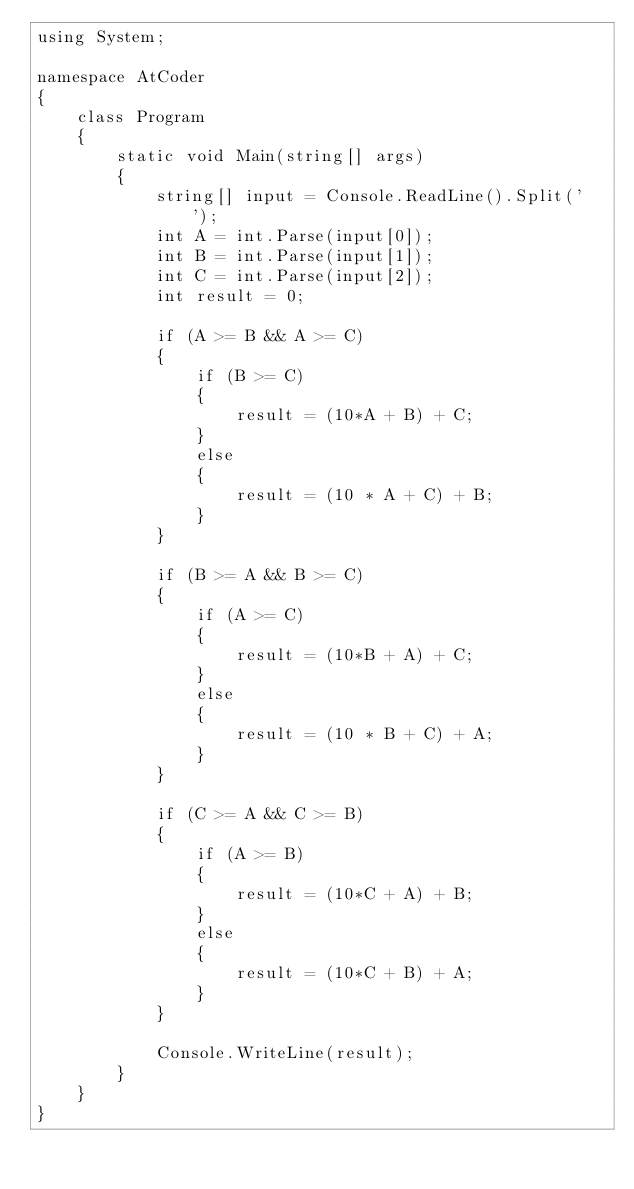<code> <loc_0><loc_0><loc_500><loc_500><_C#_>using System;

namespace AtCoder
{
    class Program
    {
        static void Main(string[] args)
        {
            string[] input = Console.ReadLine().Split(' ');
            int A = int.Parse(input[0]);
            int B = int.Parse(input[1]);
            int C = int.Parse(input[2]);
            int result = 0;
           
            if (A >= B && A >= C)
            {
                if (B >= C)
                {
                    result = (10*A + B) + C;
                }
                else
                {
                    result = (10 * A + C) + B;
                }
            }

            if (B >= A && B >= C)
            {
                if (A >= C)
                {
                    result = (10*B + A) + C;
                }
                else
                {
                    result = (10 * B + C) + A;
                }
            }

            if (C >= A && C >= B)
            {
                if (A >= B)
                {
                    result = (10*C + A) + B;
                }
                else
                {
                    result = (10*C + B) + A;
                } 
            }

            Console.WriteLine(result);
        }
    }
}</code> 